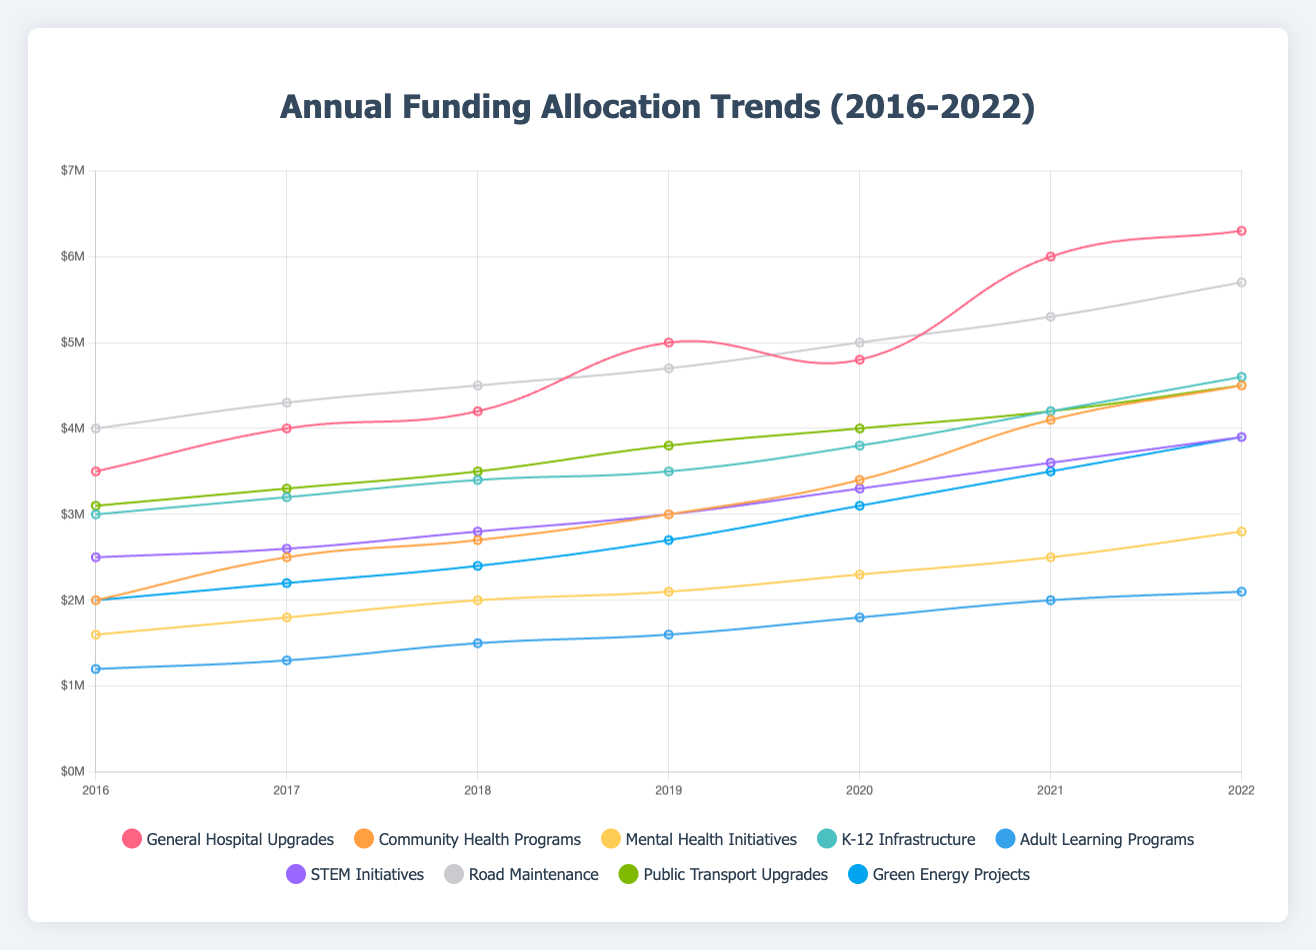Which healthcare initiative experienced the largest increase in funding between 2016 and 2022? To find this, calculate the difference in funding for each healthcare initiative from 2016 to 2022. General Hospital Upgrades increased by (6.3 - 3.5) = 2.8M, Community Health Programs by (4.5 - 2.0) = 2.5M, and Mental Health Initiatives by (2.8 - 1.6) = 1.2M. The largest increase is 2.8M for General Hospital Upgrades.
Answer: General Hospital Upgrades Which year had the highest total funding for education projects? Sum the funding for K-12 Infrastructure, Adult Learning Programs, and STEM Initiatives for each year. 2022 has the highest funding: K-12 Infrastructure (4.6M) + Adult Learning Programs (2.1M) + STEM Initiatives (3.9M) = 10.6M.
Answer: 2022 Compare the funding trend for STEM Initiatives with Mental Health Initiatives; which one consistently increased more each year? Review the annual increments for both initiatives. STEM Initiatives increased from 2.5M in 2016 to 3.9M in 2022, a consistent increase each year. Mental Health Initiatives increased from 1.6M in 2016 to 2.8M in 2022, with less consistent increments.
Answer: STEM Initiatives Which initiative had the smallest percentage increase in funding from 2016 to 2022? Calculate the percentage increase for each initiative. For example: Community Health Programs: ((4.5 - 2.0) / 2.0) * 100% = 125%, Adult Learning Programs: ((2.1 - 1.2) / 1.2) * 100% = 75%, Green Energy Projects: ((3.9 - 2.0) / 2.0) * 100% = 95%. The smallest percentage increase is 75% for Adult Learning Programs.
Answer: Adult Learning Programs What was the total funding for all infrastructure projects in 2019? Sum the funding for all infrastructure projects in 2019: Road Maintenance (4.7M) + Public Transport Upgrades (3.8M) + Green Energy Projects (2.7M) = 11.2M.
Answer: 11.2M Which educational initiative reached $4M funding first and in which year? Check the funding over the years for each initiative. K-12 Infrastructure reached 4M first in 2020.
Answer: K-12 Infrastructure, 2020 How did the funding for General Hospital Upgrades in 2021 compare to Road Maintenance in the same year? General Hospital Upgrades had 6.0M in 2021, while Road Maintenance had 5.3M.
Answer: General Hospital Upgrades had more funding 